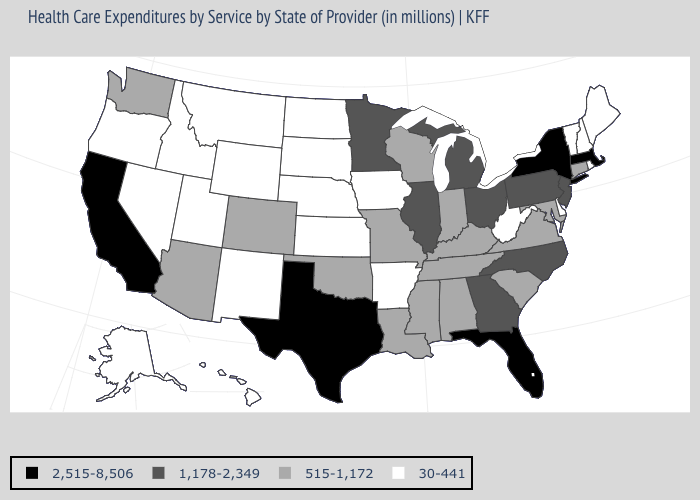Name the states that have a value in the range 515-1,172?
Be succinct. Alabama, Arizona, Colorado, Connecticut, Indiana, Kentucky, Louisiana, Maryland, Mississippi, Missouri, Oklahoma, South Carolina, Tennessee, Virginia, Washington, Wisconsin. Does South Carolina have a lower value than Florida?
Quick response, please. Yes. What is the value of Oregon?
Short answer required. 30-441. What is the lowest value in states that border Delaware?
Keep it brief. 515-1,172. Name the states that have a value in the range 30-441?
Answer briefly. Alaska, Arkansas, Delaware, Hawaii, Idaho, Iowa, Kansas, Maine, Montana, Nebraska, Nevada, New Hampshire, New Mexico, North Dakota, Oregon, Rhode Island, South Dakota, Utah, Vermont, West Virginia, Wyoming. Among the states that border Wisconsin , which have the lowest value?
Be succinct. Iowa. Name the states that have a value in the range 30-441?
Answer briefly. Alaska, Arkansas, Delaware, Hawaii, Idaho, Iowa, Kansas, Maine, Montana, Nebraska, Nevada, New Hampshire, New Mexico, North Dakota, Oregon, Rhode Island, South Dakota, Utah, Vermont, West Virginia, Wyoming. Among the states that border Texas , which have the highest value?
Keep it brief. Louisiana, Oklahoma. Among the states that border Rhode Island , which have the highest value?
Concise answer only. Massachusetts. Does Pennsylvania have the same value as Ohio?
Keep it brief. Yes. Is the legend a continuous bar?
Give a very brief answer. No. Does the first symbol in the legend represent the smallest category?
Give a very brief answer. No. Name the states that have a value in the range 1,178-2,349?
Be succinct. Georgia, Illinois, Michigan, Minnesota, New Jersey, North Carolina, Ohio, Pennsylvania. What is the highest value in the USA?
Answer briefly. 2,515-8,506. What is the value of Tennessee?
Be succinct. 515-1,172. 